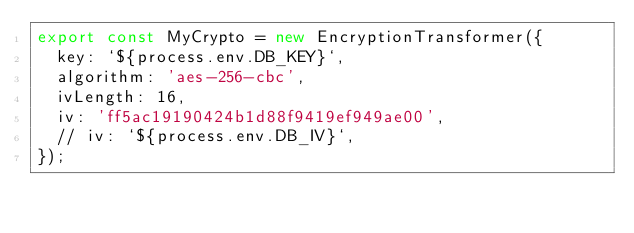<code> <loc_0><loc_0><loc_500><loc_500><_TypeScript_>export const MyCrypto = new EncryptionTransformer({
  key: `${process.env.DB_KEY}`,
  algorithm: 'aes-256-cbc',
  ivLength: 16,
  iv: 'ff5ac19190424b1d88f9419ef949ae00',
  // iv: `${process.env.DB_IV}`,
});
</code> 